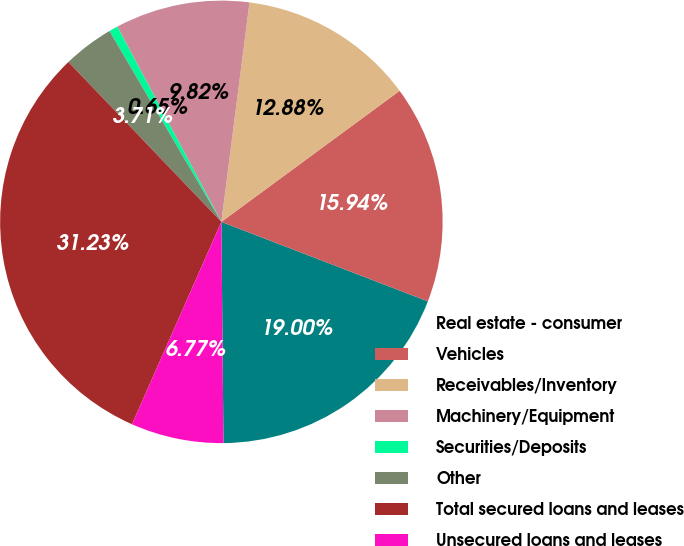Convert chart. <chart><loc_0><loc_0><loc_500><loc_500><pie_chart><fcel>Real estate - consumer<fcel>Vehicles<fcel>Receivables/Inventory<fcel>Machinery/Equipment<fcel>Securities/Deposits<fcel>Other<fcel>Total secured loans and leases<fcel>Unsecured loans and leases<nl><fcel>19.0%<fcel>15.94%<fcel>12.88%<fcel>9.82%<fcel>0.65%<fcel>3.71%<fcel>31.23%<fcel>6.77%<nl></chart> 